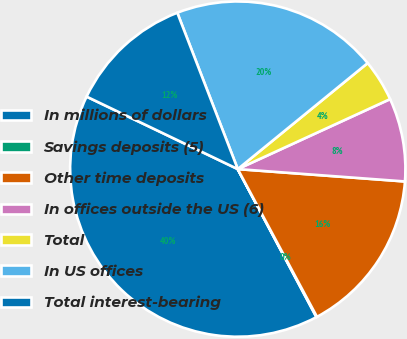<chart> <loc_0><loc_0><loc_500><loc_500><pie_chart><fcel>In millions of dollars<fcel>Savings deposits (5)<fcel>Other time deposits<fcel>In offices outside the US (6)<fcel>Total<fcel>In US offices<fcel>Total interest-bearing<nl><fcel>39.89%<fcel>0.06%<fcel>15.99%<fcel>8.03%<fcel>4.04%<fcel>19.98%<fcel>12.01%<nl></chart> 